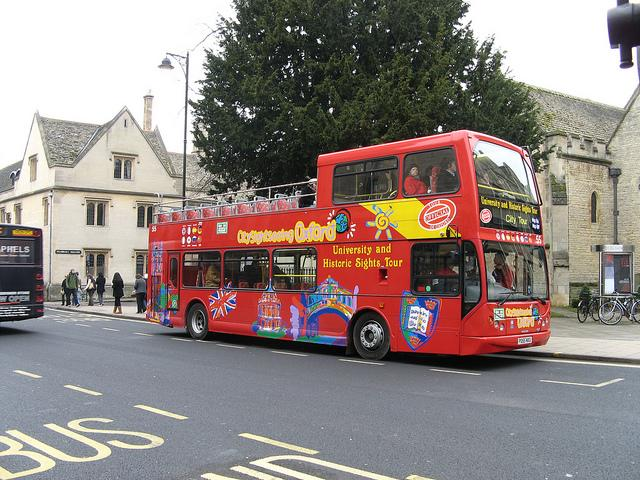Who are the passengers inside the red bus?

Choices:
A) actresses
B) tourists
C) medical workers
D) politicians tourists 